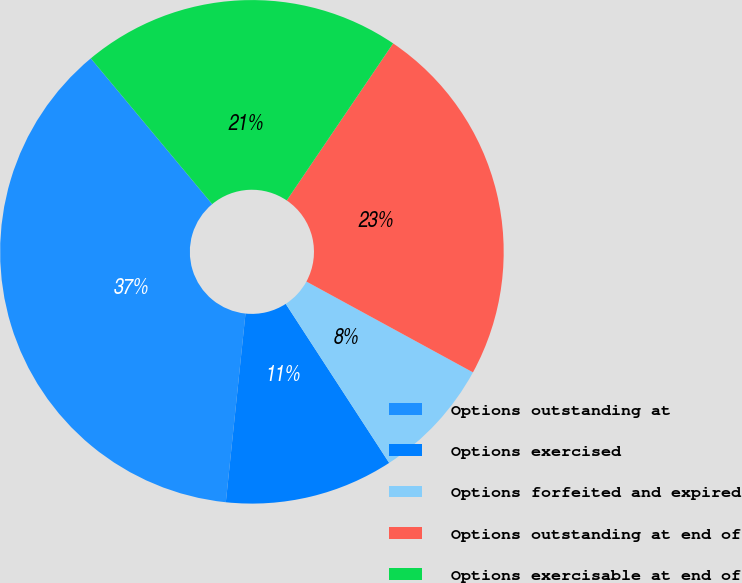Convert chart to OTSL. <chart><loc_0><loc_0><loc_500><loc_500><pie_chart><fcel>Options outstanding at<fcel>Options exercised<fcel>Options forfeited and expired<fcel>Options outstanding at end of<fcel>Options exercisable at end of<nl><fcel>37.3%<fcel>10.83%<fcel>7.88%<fcel>23.47%<fcel>20.53%<nl></chart> 